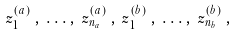Convert formula to latex. <formula><loc_0><loc_0><loc_500><loc_500>z _ { 1 } ^ { ( a ) } \, , \, . \, . \, . \, , \, z _ { n _ { a } } ^ { ( a ) } \, , \, z _ { 1 } ^ { ( b ) } \, , \, . \, . \, . \, , \, z _ { n _ { b } } ^ { ( b ) } \, ,</formula> 